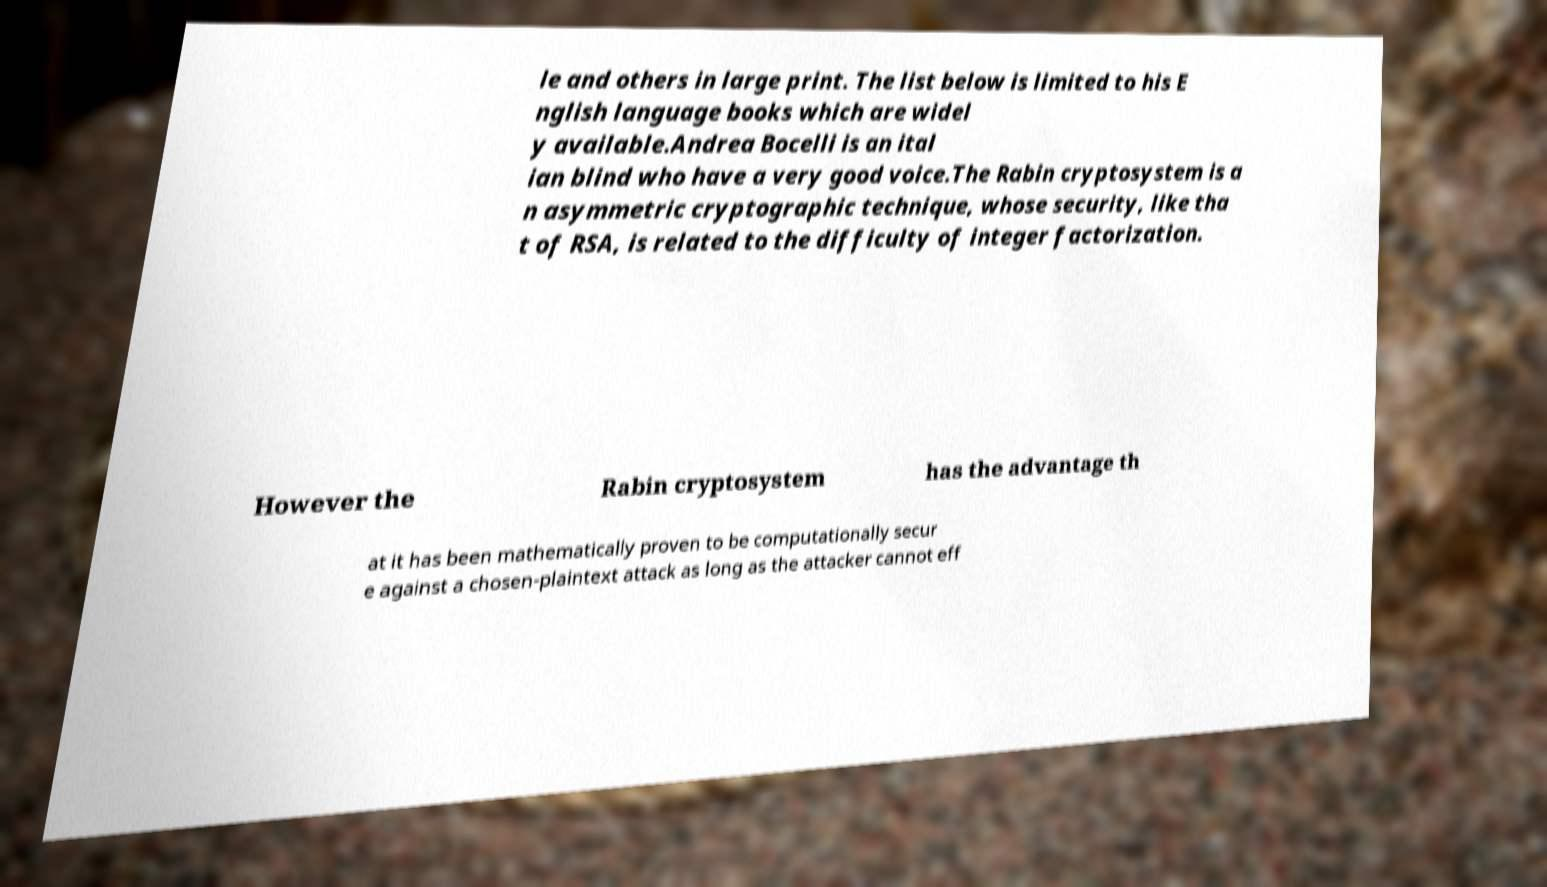There's text embedded in this image that I need extracted. Can you transcribe it verbatim? le and others in large print. The list below is limited to his E nglish language books which are widel y available.Andrea Bocelli is an ital ian blind who have a very good voice.The Rabin cryptosystem is a n asymmetric cryptographic technique, whose security, like tha t of RSA, is related to the difficulty of integer factorization. However the Rabin cryptosystem has the advantage th at it has been mathematically proven to be computationally secur e against a chosen-plaintext attack as long as the attacker cannot eff 